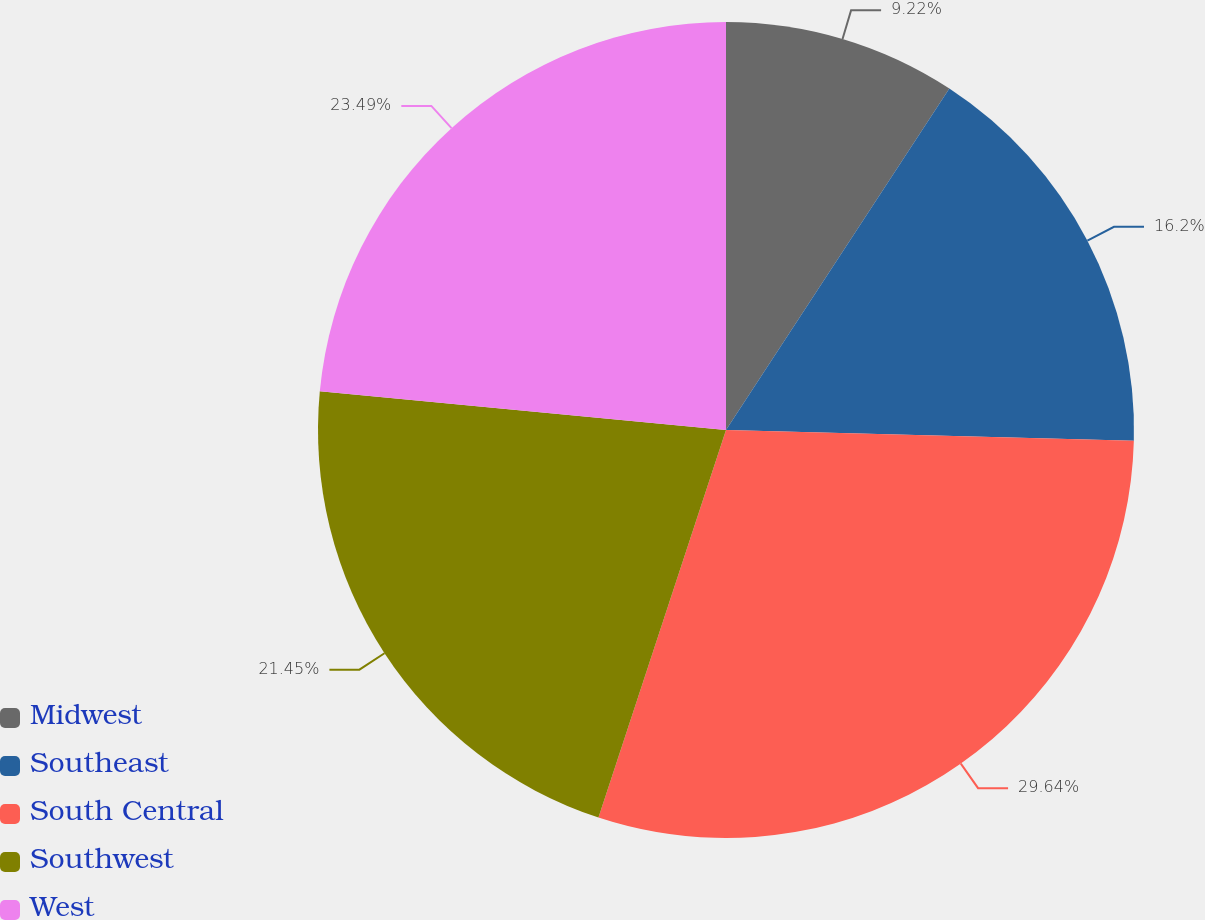Convert chart to OTSL. <chart><loc_0><loc_0><loc_500><loc_500><pie_chart><fcel>Midwest<fcel>Southeast<fcel>South Central<fcel>Southwest<fcel>West<nl><fcel>9.22%<fcel>16.2%<fcel>29.64%<fcel>21.45%<fcel>23.49%<nl></chart> 